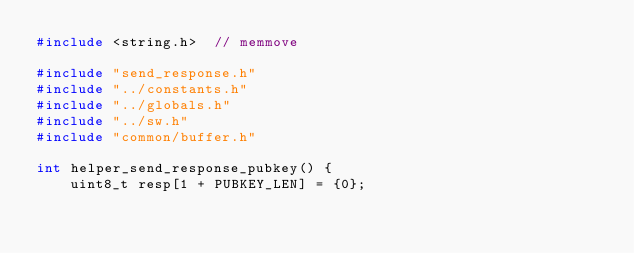Convert code to text. <code><loc_0><loc_0><loc_500><loc_500><_C_>#include <string.h>  // memmove

#include "send_response.h"
#include "../constants.h"
#include "../globals.h"
#include "../sw.h"
#include "common/buffer.h"

int helper_send_response_pubkey() {
    uint8_t resp[1 + PUBKEY_LEN] = {0};</code> 